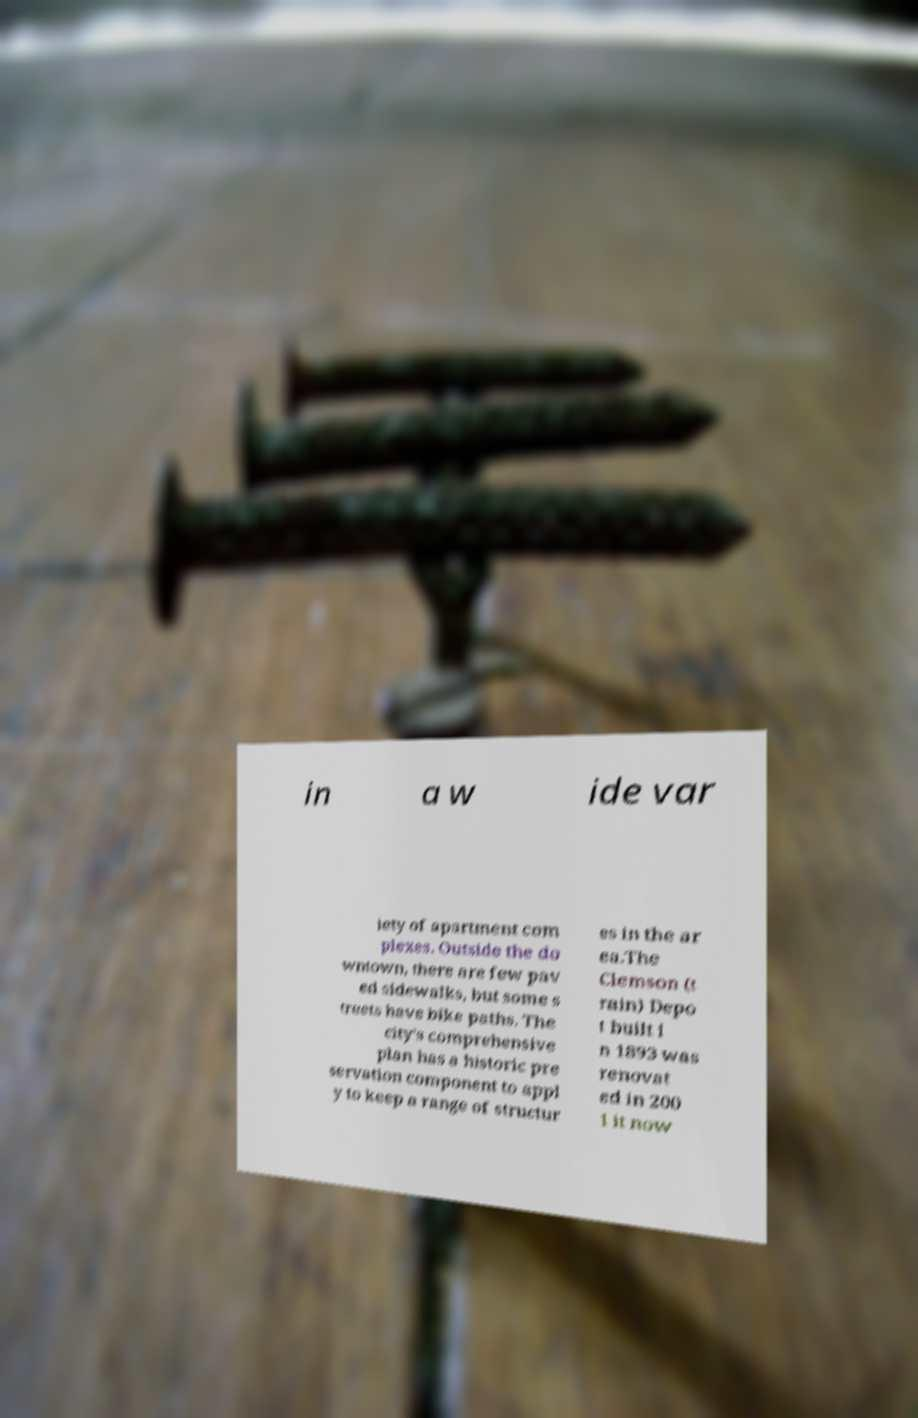Can you accurately transcribe the text from the provided image for me? in a w ide var iety of apartment com plexes. Outside the do wntown, there are few pav ed sidewalks, but some s treets have bike paths. The city's comprehensive plan has a historic pre servation component to appl y to keep a range of structur es in the ar ea.The Clemson (t rain) Depo t built i n 1893 was renovat ed in 200 1 it now 